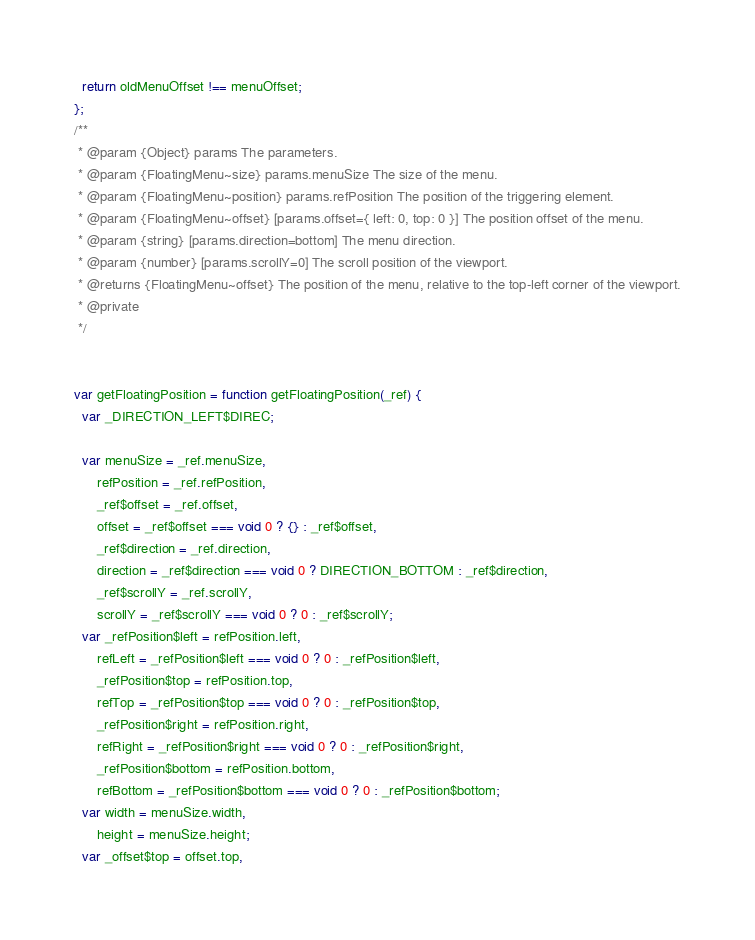<code> <loc_0><loc_0><loc_500><loc_500><_JavaScript_>  return oldMenuOffset !== menuOffset;
};
/**
 * @param {Object} params The parameters.
 * @param {FloatingMenu~size} params.menuSize The size of the menu.
 * @param {FloatingMenu~position} params.refPosition The position of the triggering element.
 * @param {FloatingMenu~offset} [params.offset={ left: 0, top: 0 }] The position offset of the menu.
 * @param {string} [params.direction=bottom] The menu direction.
 * @param {number} [params.scrollY=0] The scroll position of the viewport.
 * @returns {FloatingMenu~offset} The position of the menu, relative to the top-left corner of the viewport.
 * @private
 */


var getFloatingPosition = function getFloatingPosition(_ref) {
  var _DIRECTION_LEFT$DIREC;

  var menuSize = _ref.menuSize,
      refPosition = _ref.refPosition,
      _ref$offset = _ref.offset,
      offset = _ref$offset === void 0 ? {} : _ref$offset,
      _ref$direction = _ref.direction,
      direction = _ref$direction === void 0 ? DIRECTION_BOTTOM : _ref$direction,
      _ref$scrollY = _ref.scrollY,
      scrollY = _ref$scrollY === void 0 ? 0 : _ref$scrollY;
  var _refPosition$left = refPosition.left,
      refLeft = _refPosition$left === void 0 ? 0 : _refPosition$left,
      _refPosition$top = refPosition.top,
      refTop = _refPosition$top === void 0 ? 0 : _refPosition$top,
      _refPosition$right = refPosition.right,
      refRight = _refPosition$right === void 0 ? 0 : _refPosition$right,
      _refPosition$bottom = refPosition.bottom,
      refBottom = _refPosition$bottom === void 0 ? 0 : _refPosition$bottom;
  var width = menuSize.width,
      height = menuSize.height;
  var _offset$top = offset.top,</code> 